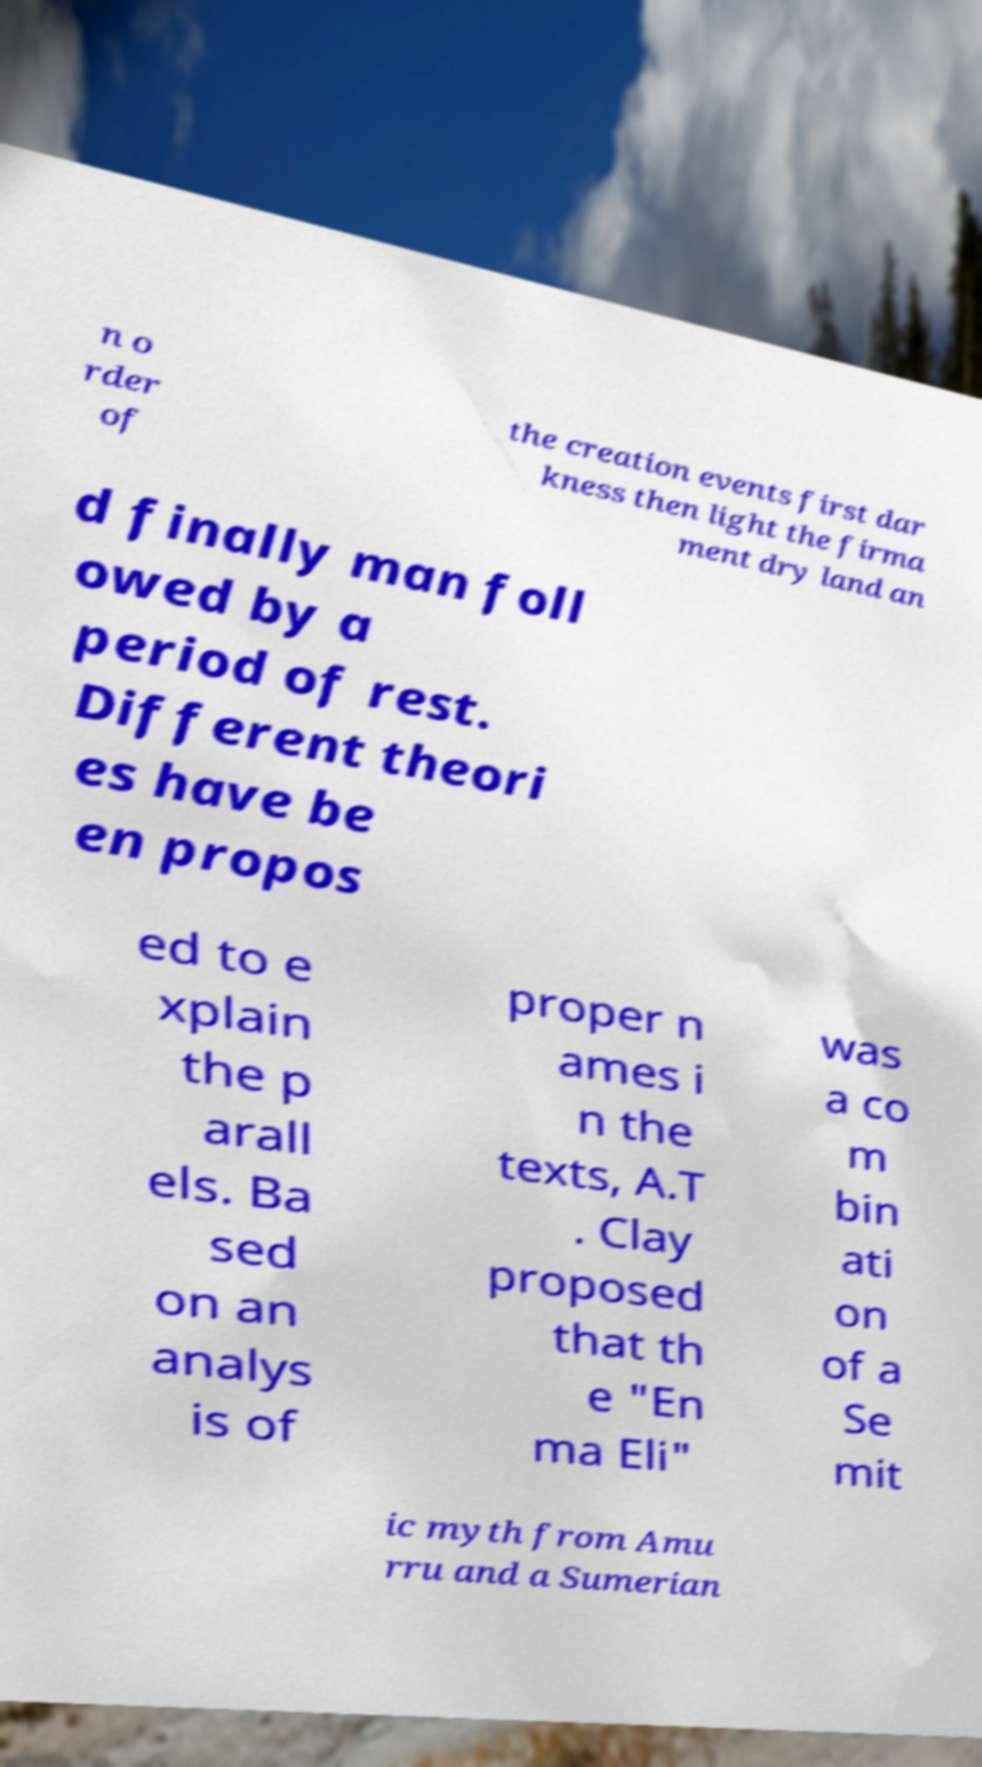Could you extract and type out the text from this image? n o rder of the creation events first dar kness then light the firma ment dry land an d finally man foll owed by a period of rest. Different theori es have be en propos ed to e xplain the p arall els. Ba sed on an analys is of proper n ames i n the texts, A.T . Clay proposed that th e "En ma Eli" was a co m bin ati on of a Se mit ic myth from Amu rru and a Sumerian 